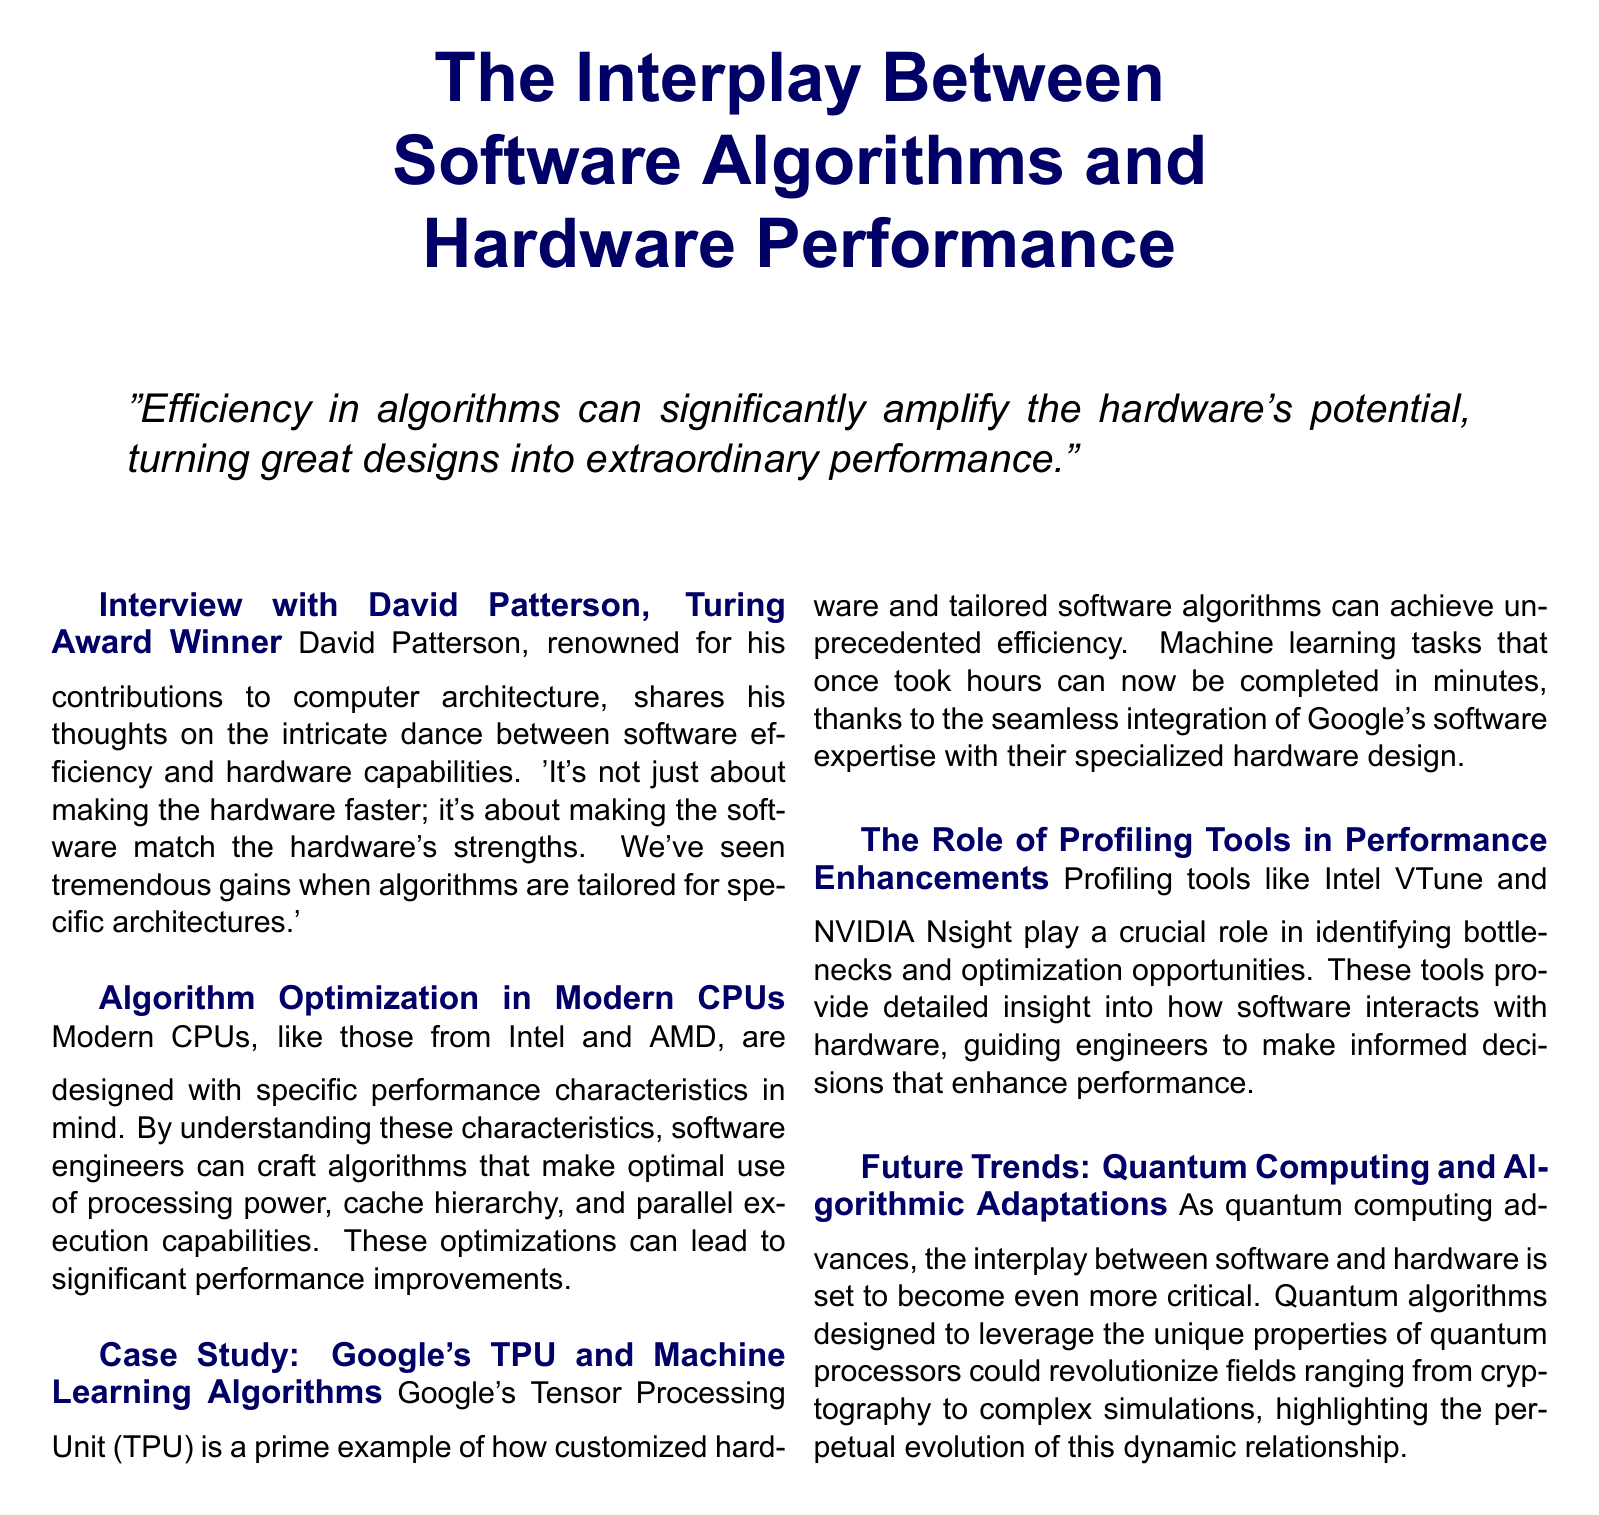What is the name of the Turing Award Winner interviewed? The document mentions David Patterson as the Turing Award Winner who discusses the relationship between software efficiency and hardware capabilities.
Answer: David Patterson What is a key benefit of algorithm optimization in modern CPUs? The document states that optimization can lead to significant performance improvements by leveraging specific performance characteristics of CPUs.
Answer: Performance improvements What example of hardware paired with tailored software is mentioned? The document provides Google's Tensor Processing Unit (TPU) as a prime example of this integration.
Answer: Google's TPU What profiling tool is mentioned for enhancing performance? The document lists Intel VTune as one of the critical profiling tools used to identify bottlenecks and optimization opportunities.
Answer: Intel VTune What future technology trend is highlighted in the document? The document discusses quantum computing as a future trend that will affect the interplay between software and hardware.
Answer: Quantum computing What is the central theme of the quote at the beginning? The quote emphasizes how the efficiency of algorithms can enhance the potential of hardware designs, indicating a close relationship between the two.
Answer: Efficiency in algorithms How do customized algorithms affect machine learning tasks according to the document? The document states that customized algorithms enable machine learning tasks that used to take hours to be completed in minutes.
Answer: In minutes What role do profiling tools play according to the document? Profiling tools are described as providing insights into software interactions with hardware, guiding performance enhancements.
Answer: Identify bottlenecks What is the document type of this layout? The structured layout, with interviews and insights, suggests that this document is a magazine article.
Answer: Magazine article 